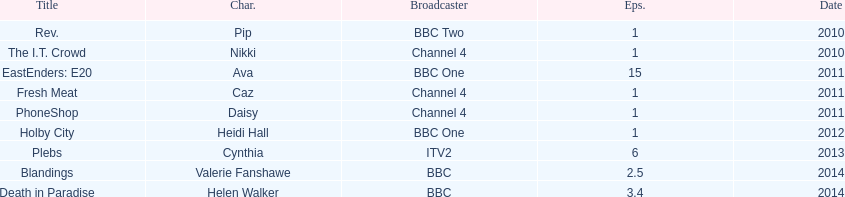How many titles have at least 5 episodes? 2. 